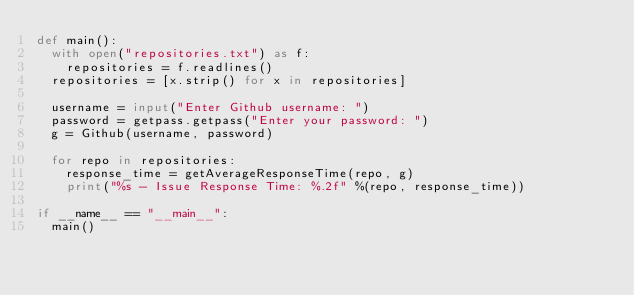Convert code to text. <code><loc_0><loc_0><loc_500><loc_500><_Python_>def main():
  with open("repositories.txt") as f:
    repositories = f.readlines()
  repositories = [x.strip() for x in repositories]
  
  username = input("Enter Github username: ")
  password = getpass.getpass("Enter your password: ")
  g = Github(username, password)

  for repo in repositories:
    response_time = getAverageResponseTime(repo, g)
    print("%s - Issue Response Time: %.2f" %(repo, response_time))

if __name__ == "__main__":
  main()
</code> 